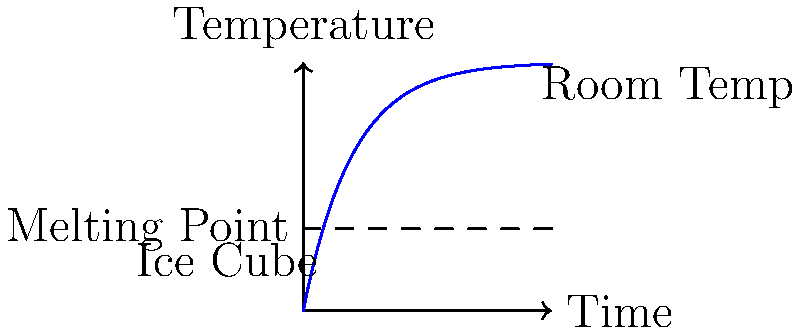In a time-lapse experiment, you're observing an ice cube melting at room temperature. The graph shows the temperature change over time. If the melting point of ice is 0°C (32°F) and room temperature is 20°C (68°F), estimate how long it would take for the ice cube to completely melt based on the curve shown. To estimate the melting time, let's follow these steps:

1. Understand the graph:
   - The x-axis represents time, and the y-axis represents temperature.
   - The blue curve shows how the temperature of the ice cube changes over time.

2. Identify key points:
   - The melting point of ice (0°C or 32°F) is about 1/3 of the way up the y-axis.
   - Room temperature (20°C or 68°F) is near the top of the graph.

3. Analyze the curve:
   - The curve starts steep and then gradually levels off.
   - This represents the ice cube warming quickly at first, then more slowly as it approaches room temperature.

4. Estimate the melting time:
   - The ice cube will be fully melted when its temperature reaches the melting point (0°C or 32°F).
   - This occurs where the curve intersects the dashed line representing the melting point.
   - From the graph, this intersection appears to be around 40-50% of the way along the x-axis.

5. Conclude:
   - Since the x-axis represents the total time of the experiment, we can estimate that the ice cube will be fully melted about halfway through the time-lapse.
   - This would be approximately 50% of the total experiment time.
Answer: Approximately 50% of the total experiment time 